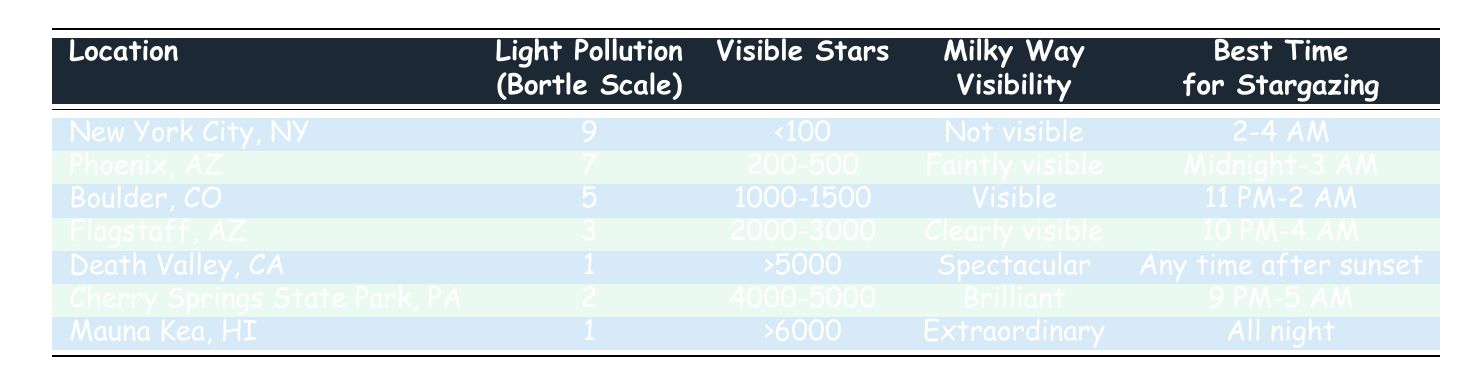What is the light pollution level of Death Valley, CA? Death Valley, CA is listed under the "Light Pollution (Bortle Scale)" column with a value of 1.
Answer: 1 How many visible stars can be seen in Boulder, CO? The "Visible Stars" column for Boulder, CO indicates a range of 1000-1500 stars that can be seen.
Answer: 1000-1500 Which location has the best Milky Way visibility? Death Valley, CA has "Spectacular" visibility of the Milky Way, which is the highest rating in the table for Milky Way visibility.
Answer: Death Valley, CA Are stars visible in New York City, NY? The table states that in New York City, NY, the visible stars are listed as "<100," indicating very few stars can be seen.
Answer: No What is the average light pollution level for rural areas, represented by locations like Death Valley, Cherry Springs State Park, and Mauna Kea? The Bortle Scale values for these three locations are 1 (Death Valley), 2 (Cherry Springs), and 1 (Mauna Kea). The average is (1 + 2 + 1) / 3 = 1.33, rounding to 1.
Answer: 1.33 Which location allows stargazing all night? Mauna Kea, HI is indicated to have ideal stargazing conditions "All night," according to the "Best Time for Stargazing" column.
Answer: Mauna Kea, HI How does the stargazing time in Flagstaff, AZ compare with that of Phoenix, AZ? Flagstaff recommends stargazing from 10 PM to 4 AM, while Phoenix suggests the time frame of Midnight to 3 AM. Comparing the two, Flagstaff has a longer stargazing recommendation.
Answer: Flagstaff has a longer stargazing time Does Flagstaff, AZ have more visible stars than Phoenix, AZ? The table lists Flagstaff, AZ with 2000-3000 visible stars and Phoenix, AZ with 200-500 visible stars, indicating that Flagstaff can see more stars than Phoenix.
Answer: Yes Which location has the latest suggested time for stargazing? Checking the "Best Time for Stargazing" column, Cherry Springs State Park, PA is indicated to have the latest suggested time from 9 PM to 5 AM.
Answer: Cherry Springs State Park, PA 